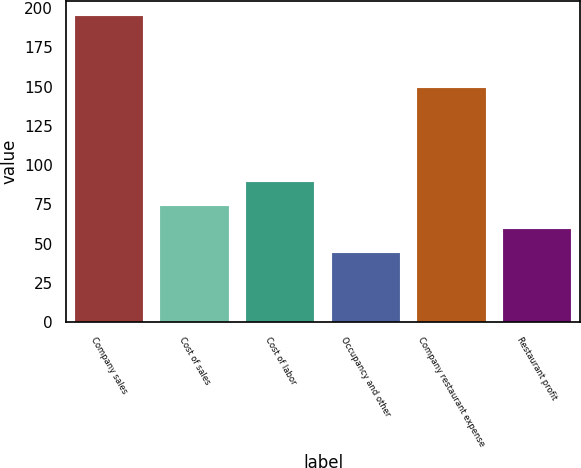Convert chart to OTSL. <chart><loc_0><loc_0><loc_500><loc_500><bar_chart><fcel>Company sales<fcel>Cost of sales<fcel>Cost of labor<fcel>Occupancy and other<fcel>Company restaurant expense<fcel>Restaurant profit<nl><fcel>195<fcel>74.2<fcel>89.3<fcel>44<fcel>149<fcel>59.1<nl></chart> 